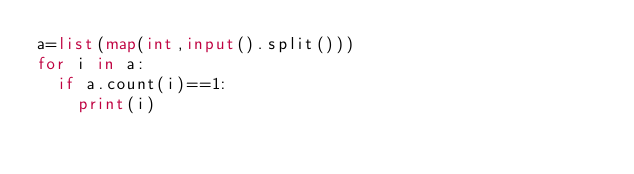<code> <loc_0><loc_0><loc_500><loc_500><_Python_>a=list(map(int,input().split()))
for i in a:
  if a.count(i)==1:
    print(i)</code> 